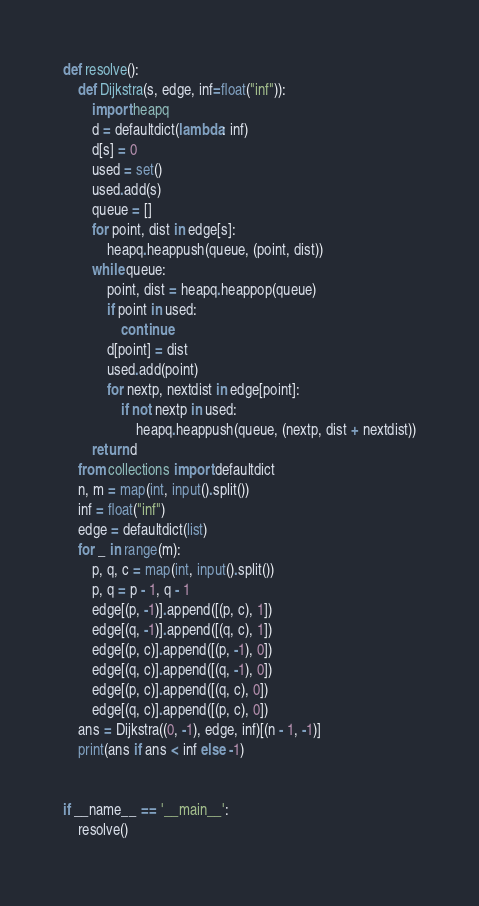<code> <loc_0><loc_0><loc_500><loc_500><_Python_>def resolve():
    def Dijkstra(s, edge, inf=float("inf")):
        import heapq
        d = defaultdict(lambda: inf)
        d[s] = 0
        used = set()
        used.add(s)
        queue = []
        for point, dist in edge[s]:
            heapq.heappush(queue, (point, dist))
        while queue:
            point, dist = heapq.heappop(queue)
            if point in used:
                continue
            d[point] = dist
            used.add(point)
            for nextp, nextdist in edge[point]:
                if not nextp in used:
                    heapq.heappush(queue, (nextp, dist + nextdist))
        return d
    from collections import defaultdict
    n, m = map(int, input().split())
    inf = float("inf")
    edge = defaultdict(list)
    for _ in range(m):
        p, q, c = map(int, input().split())
        p, q = p - 1, q - 1
        edge[(p, -1)].append([(p, c), 1])
        edge[(q, -1)].append([(q, c), 1])
        edge[(p, c)].append([(p, -1), 0])
        edge[(q, c)].append([(q, -1), 0])
        edge[(p, c)].append([(q, c), 0])
        edge[(q, c)].append([(p, c), 0])
    ans = Dijkstra((0, -1), edge, inf)[(n - 1, -1)]
    print(ans if ans < inf else -1)


if __name__ == '__main__':
    resolve()
</code> 